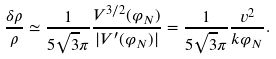Convert formula to latex. <formula><loc_0><loc_0><loc_500><loc_500>\frac { \delta \rho } { \rho } \simeq \frac { 1 } { 5 \sqrt { 3 } \pi } \frac { V ^ { 3 / 2 } ( \varphi _ { N } ) } { | V ^ { \prime } ( \varphi _ { N } ) | } = \frac { 1 } { 5 \sqrt { 3 } \pi } \frac { v ^ { 2 } } { k \varphi _ { N } } .</formula> 